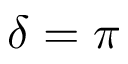Convert formula to latex. <formula><loc_0><loc_0><loc_500><loc_500>\delta = \pi</formula> 